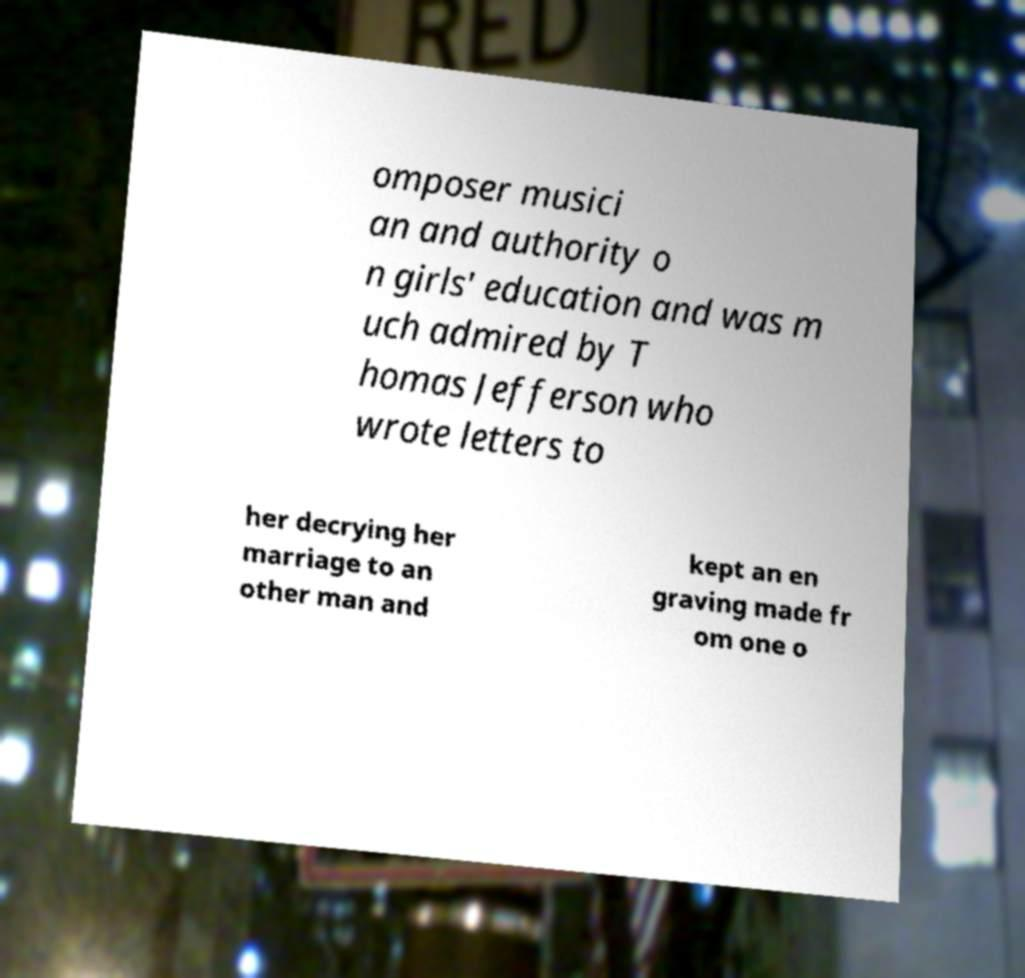Can you accurately transcribe the text from the provided image for me? omposer musici an and authority o n girls' education and was m uch admired by T homas Jefferson who wrote letters to her decrying her marriage to an other man and kept an en graving made fr om one o 